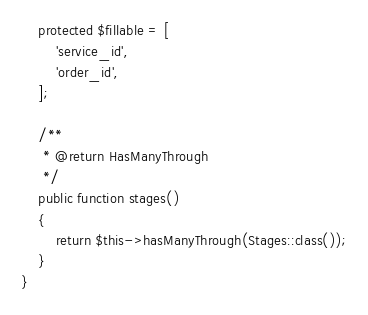<code> <loc_0><loc_0><loc_500><loc_500><_PHP_>    protected $fillable = [
        'service_id',
        'order_id',
    ];

    /**
     * @return HasManyThrough
     */
    public function stages()
    {
        return $this->hasManyThrough(Stages::class());
    }
}
</code> 